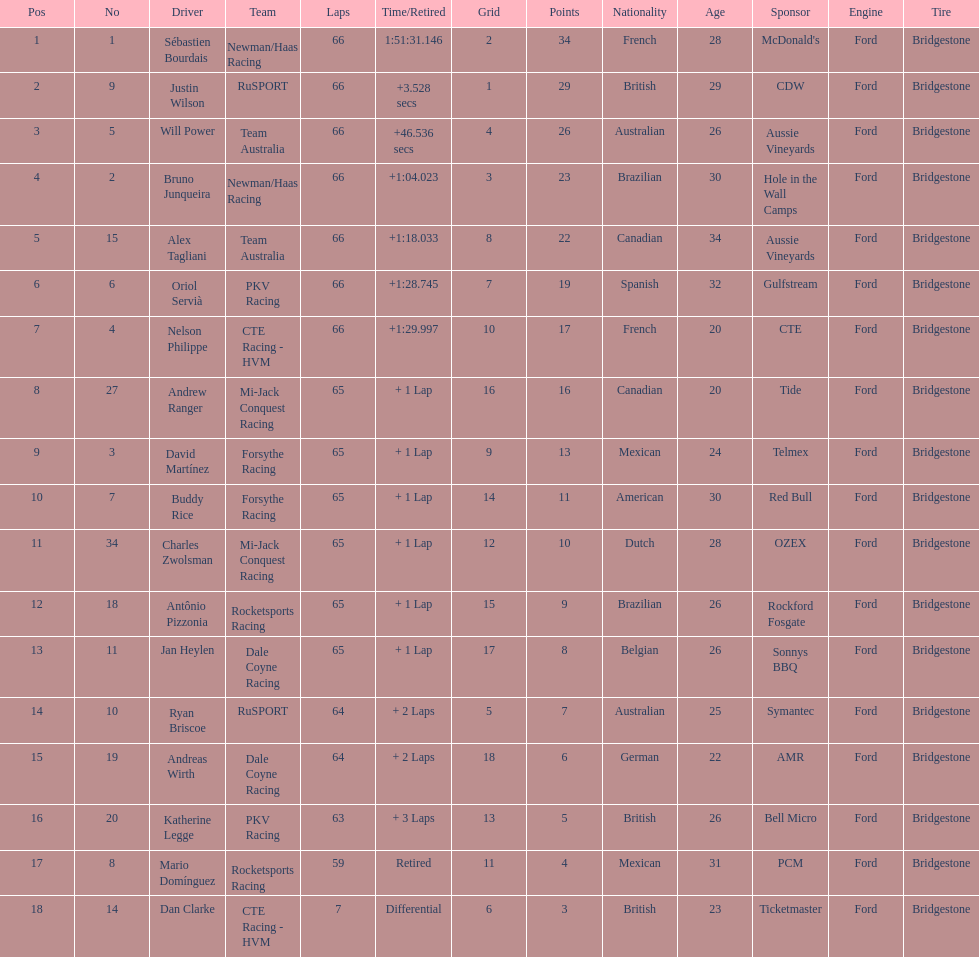Give me the full table as a dictionary. {'header': ['Pos', 'No', 'Driver', 'Team', 'Laps', 'Time/Retired', 'Grid', 'Points', 'Nationality', 'Age', 'Sponsor', 'Engine', 'Tire'], 'rows': [['1', '1', 'Sébastien Bourdais', 'Newman/Haas Racing', '66', '1:51:31.146', '2', '34', 'French', '28', "McDonald's", 'Ford', 'Bridgestone'], ['2', '9', 'Justin Wilson', 'RuSPORT', '66', '+3.528 secs', '1', '29', 'British', '29', 'CDW', 'Ford', 'Bridgestone'], ['3', '5', 'Will Power', 'Team Australia', '66', '+46.536 secs', '4', '26', 'Australian', '26', 'Aussie Vineyards', 'Ford', 'Bridgestone'], ['4', '2', 'Bruno Junqueira', 'Newman/Haas Racing', '66', '+1:04.023', '3', '23', 'Brazilian', '30', 'Hole in the Wall Camps', 'Ford', 'Bridgestone'], ['5', '15', 'Alex Tagliani', 'Team Australia', '66', '+1:18.033', '8', '22', 'Canadian', '34', 'Aussie Vineyards', 'Ford', 'Bridgestone'], ['6', '6', 'Oriol Servià', 'PKV Racing', '66', '+1:28.745', '7', '19', 'Spanish', '32', 'Gulfstream', 'Ford', 'Bridgestone'], ['7', '4', 'Nelson Philippe', 'CTE Racing - HVM', '66', '+1:29.997', '10', '17', 'French', '20', 'CTE', 'Ford', 'Bridgestone'], ['8', '27', 'Andrew Ranger', 'Mi-Jack Conquest Racing', '65', '+ 1 Lap', '16', '16', 'Canadian', '20', 'Tide', 'Ford', 'Bridgestone'], ['9', '3', 'David Martínez', 'Forsythe Racing', '65', '+ 1 Lap', '9', '13', 'Mexican', '24', 'Telmex', 'Ford', 'Bridgestone'], ['10', '7', 'Buddy Rice', 'Forsythe Racing', '65', '+ 1 Lap', '14', '11', 'American', '30', 'Red Bull', 'Ford', 'Bridgestone'], ['11', '34', 'Charles Zwolsman', 'Mi-Jack Conquest Racing', '65', '+ 1 Lap', '12', '10', 'Dutch', '28', 'OZEX', 'Ford', 'Bridgestone'], ['12', '18', 'Antônio Pizzonia', 'Rocketsports Racing', '65', '+ 1 Lap', '15', '9', 'Brazilian', '26', 'Rockford Fosgate', 'Ford', 'Bridgestone'], ['13', '11', 'Jan Heylen', 'Dale Coyne Racing', '65', '+ 1 Lap', '17', '8', 'Belgian', '26', 'Sonnys BBQ', 'Ford', 'Bridgestone'], ['14', '10', 'Ryan Briscoe', 'RuSPORT', '64', '+ 2 Laps', '5', '7', 'Australian', '25', 'Symantec', 'Ford', 'Bridgestone'], ['15', '19', 'Andreas Wirth', 'Dale Coyne Racing', '64', '+ 2 Laps', '18', '6', 'German', '22', 'AMR', 'Ford', 'Bridgestone'], ['16', '20', 'Katherine Legge', 'PKV Racing', '63', '+ 3 Laps', '13', '5', 'British', '26', 'Bell Micro', 'Ford', 'Bridgestone'], ['17', '8', 'Mario Domínguez', 'Rocketsports Racing', '59', 'Retired', '11', '4', 'Mexican', '31', 'PCM', 'Ford', 'Bridgestone'], ['18', '14', 'Dan Clarke', 'CTE Racing - HVM', '7', 'Differential', '6', '3', 'British', '23', 'Ticketmaster', 'Ford', 'Bridgestone']]} What is the number of laps dan clarke completed? 7. 